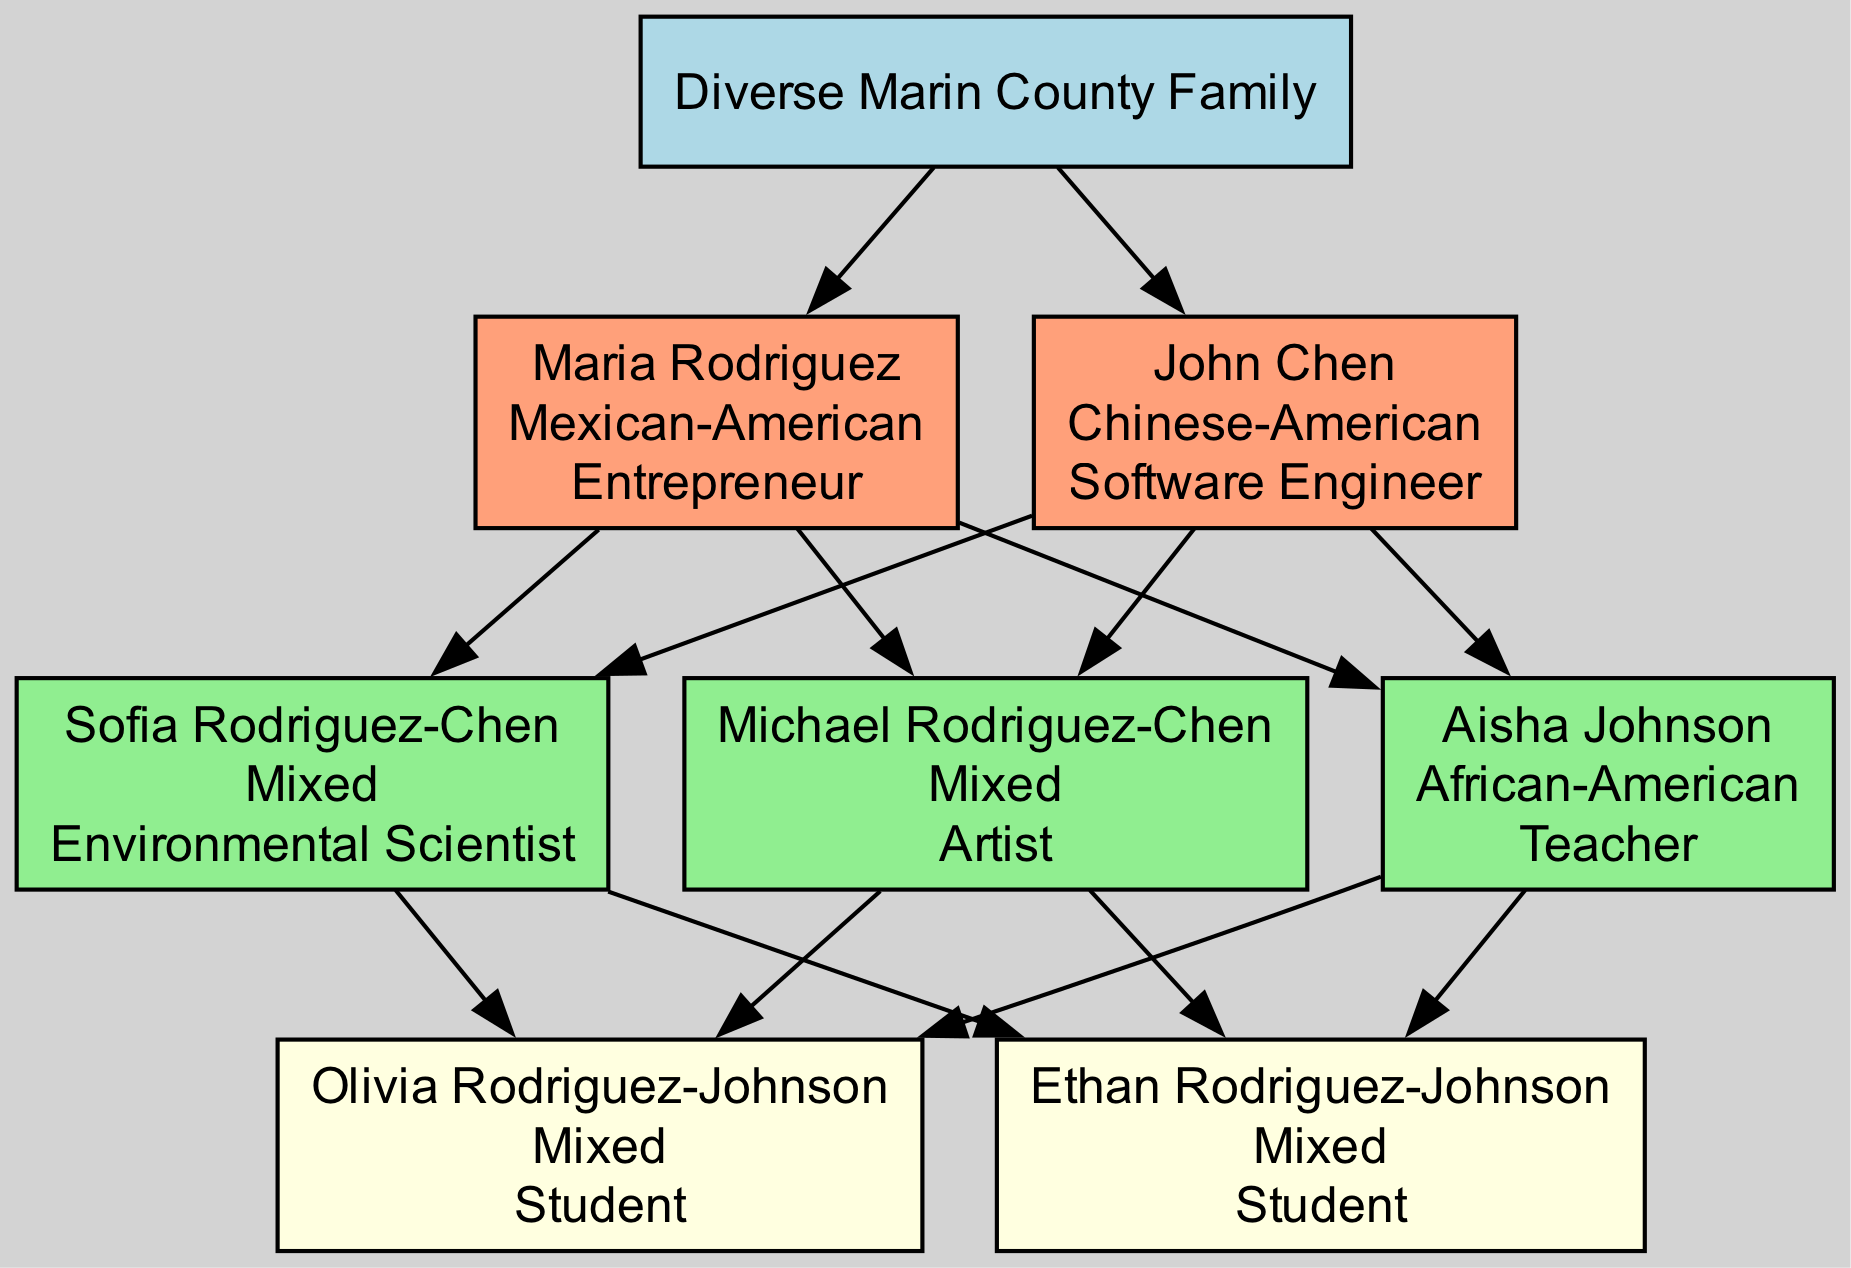What is the ethnicity of Maria Rodriguez? The diagram states that Maria Rodriguez is "Mexican-American" as indicated on her node.
Answer: Mexican-American How many members are there in the second generation? The second generation has three members listed: Sofia Rodriguez-Chen, Michael Rodriguez-Chen, and Aisha Johnson.
Answer: 3 Who is an Environmental Scientist in the family tree? Looking at the nodes, Sofia Rodriguez-Chen is identified as "Environmental Scientist."
Answer: Sofia Rodriguez-Chen What is the common ethnicity of Olivia and Ethan Rodriguez-Johnson? Both Olivia and Ethan Rodriguez-Johnson are labeled as "Mixed" in the diagram.
Answer: Mixed Which generation does Aisha Johnson belong to? Aisha Johnson appears in the second generation, as can be seen in her grouping with Sofia and Michael.
Answer: 2 Identify the occupation of Michael Rodriguez-Chen. The diagram clearly states that Michael Rodriguez-Chen's occupation is "Artist" as presented on his node.
Answer: Artist How many total members does the family have, including all generations? Counting all nodes: 2 members from the first generation, 3 from the second, and 2 from the third gives a total of 7 members.
Answer: 7 Which member has an occupation of Teacher? The node identifying Aisha Johnson clearly states her occupation, which is "Teacher."
Answer: Aisha Johnson How are Sofia and Michael Rodriguez-Chen related to Maria Rodriguez? Both Sofia and Michael Rodriguez-Chen are the children of Maria Rodriguez and John Chen, as they are in the second generation below them.
Answer: Children 